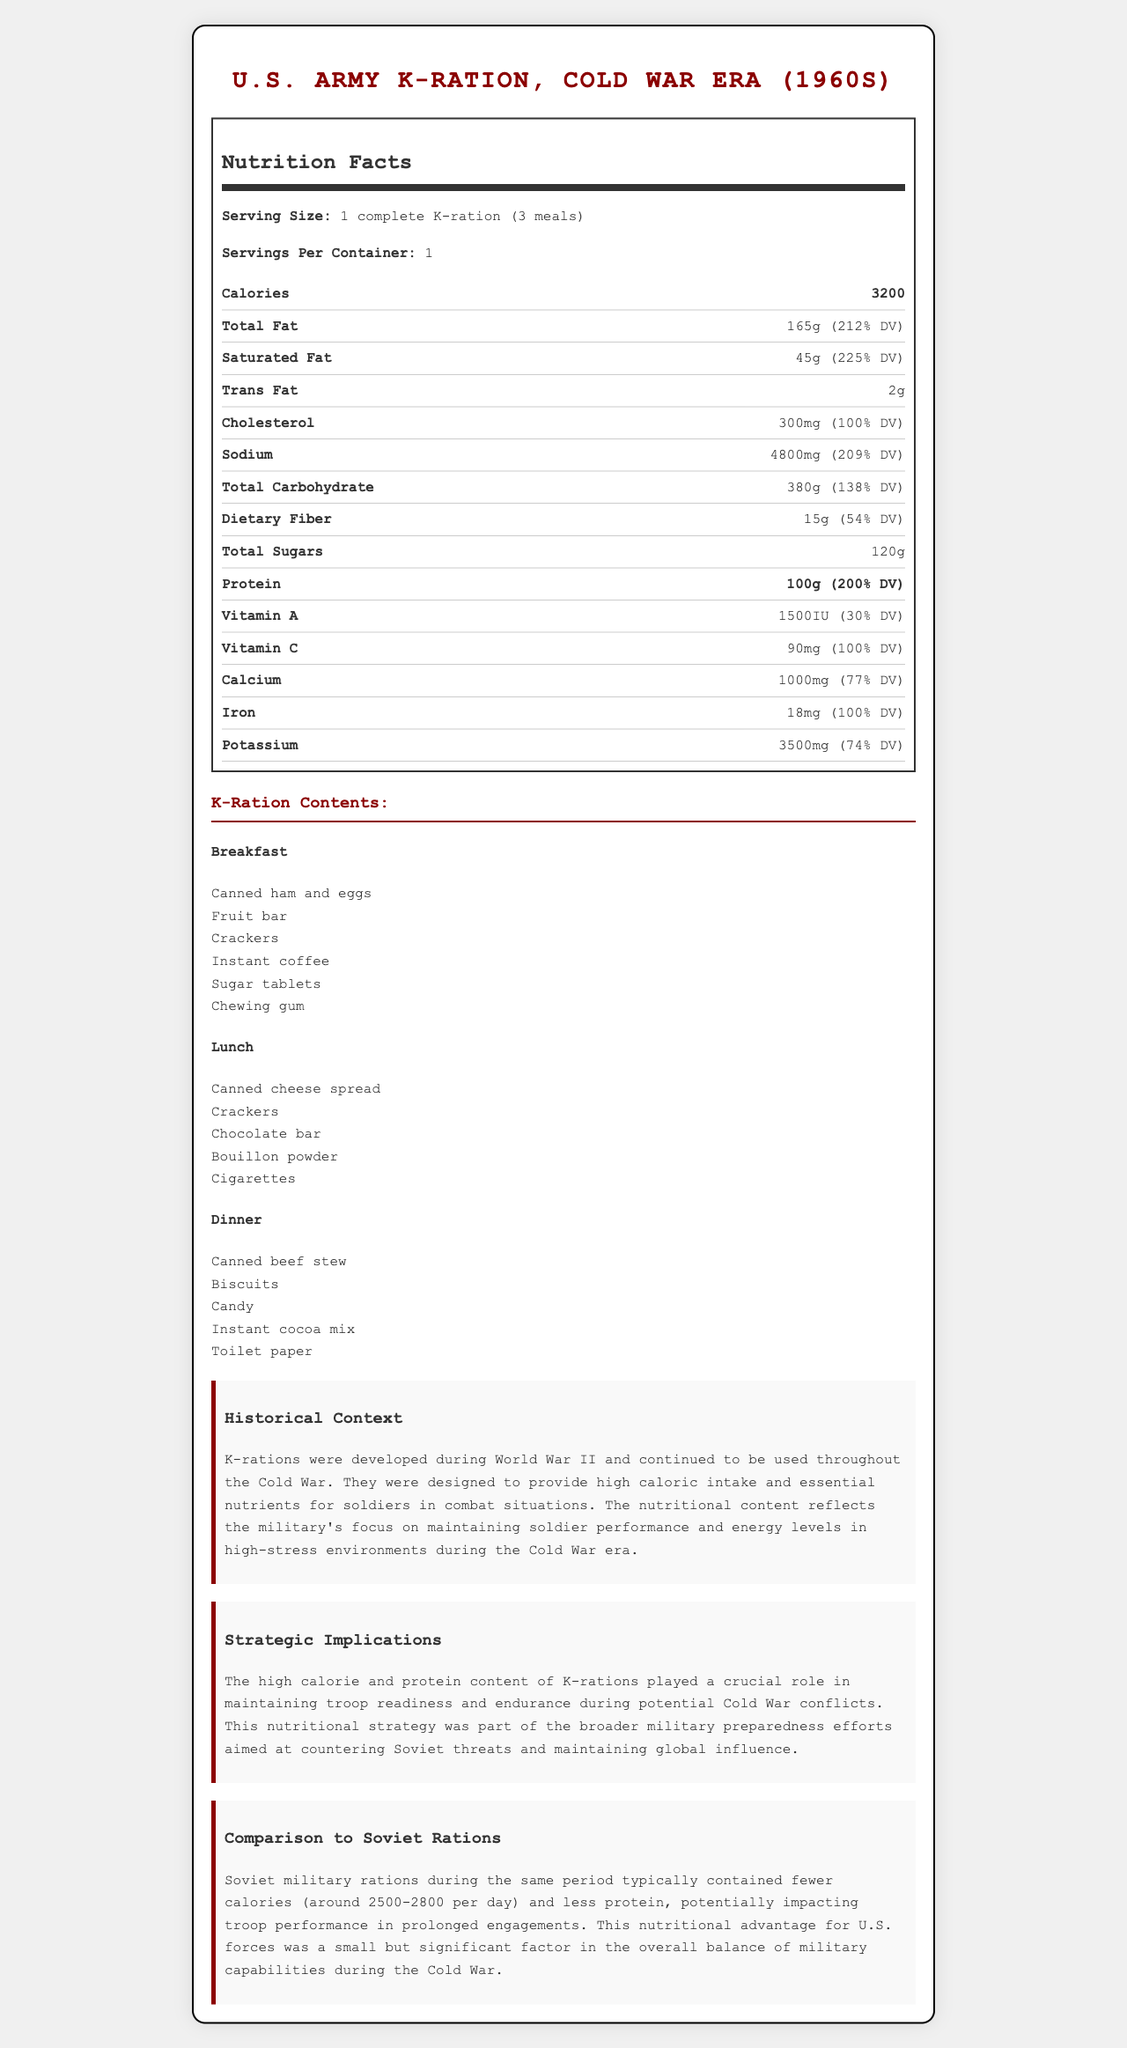what is the serving size of the K-ration? According to the document, the serving size is listed as "1 complete K-ration (3 meals)".
Answer: 1 complete K-ration (3 meals) how many calories does one serving of the K-ration provide? The nutrition label specifies that one serving of the K-ration provides 3200 calories.
Answer: 3200 calories what is the total protein content per K-ration? The document indicates that the K-ration contains 100 grams of protein per serving.
Answer: 100 grams how much sodium is in the K-ration? The amount of sodium in the K-ration is listed as 4800 mg in the nutritional content table.
Answer: 4800 mg what are the three meals included in the K-ration? The document lists the three meals as Breakfast, Lunch, and Dinner in the specific contents section.
Answer: Breakfast, Lunch, Dinner what was the historical purpose of K-rations? The historical context section explains that K-rations were developed to provide high caloric intake and essential nutrients to maintain soldier performance in combat situations.
Answer: To provide high caloric intake and essential nutrients for soldiers which nutrient has the highest daily value percentage? A. Protein B. Vitamin C C. Saturated Fat D. Calcium Saturated fat has the highest daily value percentage at 225%.
Answer: C. Saturated Fat how many total grams of sugars are in the K-ration? A. 150g B. 120g C. 80g D. 200g The nutrition facts indicate that the total sugars are 120 grams.
Answer: B. 120g is the protein content of the K-ration more than 90 grams? The document states that the protein content is 100 grams, which is more than 90 grams.
Answer: Yes what is the strategic implication of the high calorie and protein content of K-rations? The document indicates that the high calorie and protein content was part of broader military preparedness efforts aimed at countering Soviet threats and maintaining global influence.
Answer: It played a crucial role in maintaining troop readiness and endurance during potential conflicts. summarize the main idea of this document. The document focuses on the nutritional content and strategic importance of Cold War-era K-rations, explaining how they were intended to support soldier endurance and readiness, along with a comparison to Soviet military rations.
Answer: The document provides detailed nutritional information about the U.S. Army K-Ration from the Cold War era, highlighting its high calorie and protein content designed for maintaining soldier performance. It also discusses the historical context and strategic implications, as well as a comparison to Soviet rations. what is the exact composition of the dinner meal in the K-ration? The dinner meal includes Canned beef stew, Biscuits, Candy, Instant cocoa mix, and Toilet paper as per the meal contents section.
Answer: Canned beef stew, Biscuits, Candy, Instant cocoa mix, Toilet paper how much dietary fiber does the K-ration provide? The nutrition label shows that the K-ration provides 15 grams of dietary fiber.
Answer: 15 grams compare the daily value percentage of calcium and iron in the K-ration. According to the nutritional content, calcium has a daily value percentage of 77%, while iron has a daily value percentage of 100%.
Answer: Calcium: 77%, Iron: 100% does the document provide information about the specific brands or manufacturers of the K-ration items? The document does not mention specific brands or manufacturers of the K-ration items.
Answer: Not enough information 